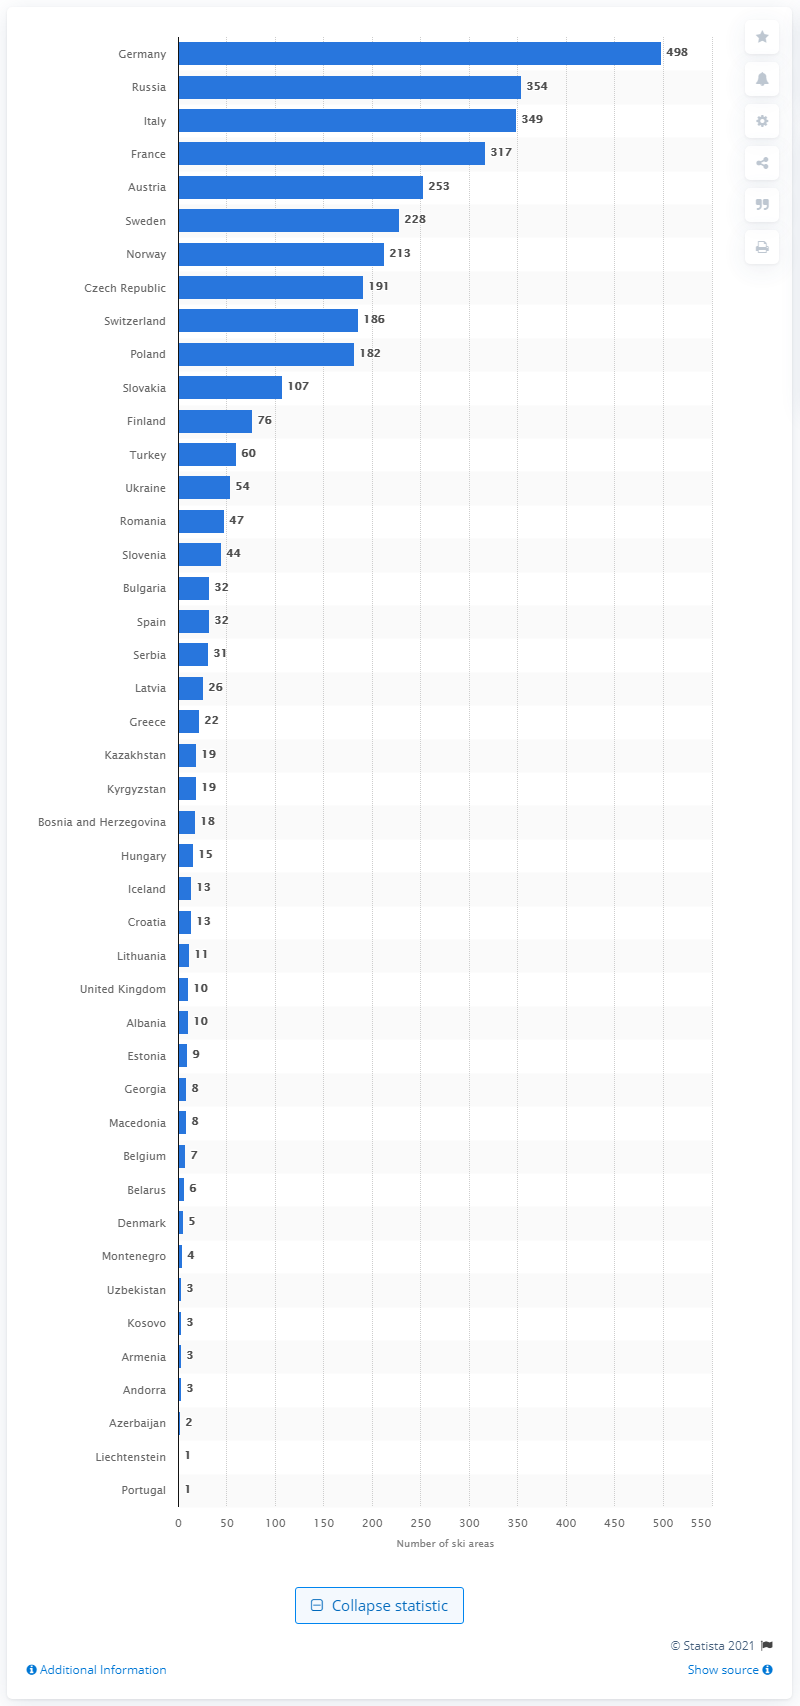Mention a couple of crucial points in this snapshot. Germany is a leading destination for skiing in Europe. In 2020, Germany had a total of 498 ski areas available for visitors to enjoy. 